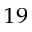Convert formula to latex. <formula><loc_0><loc_0><loc_500><loc_500>^ { 1 9 }</formula> 